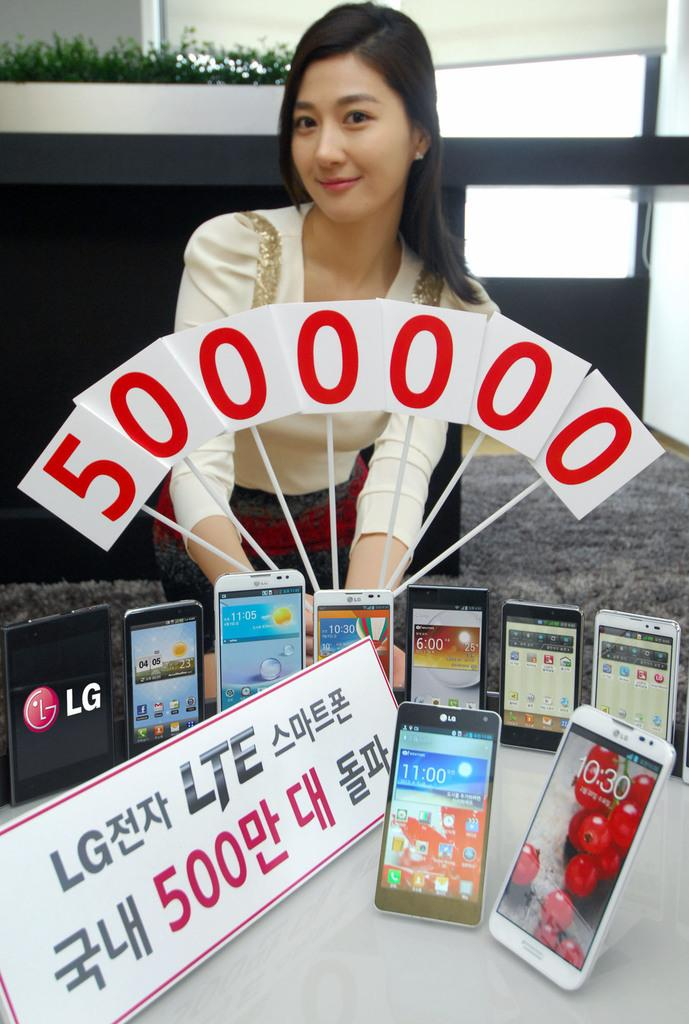Provide a one-sentence caption for the provided image. A display table of LG LTE cells and an oriental girl holding white flags with red ink an amount of money for the price of the phones . 